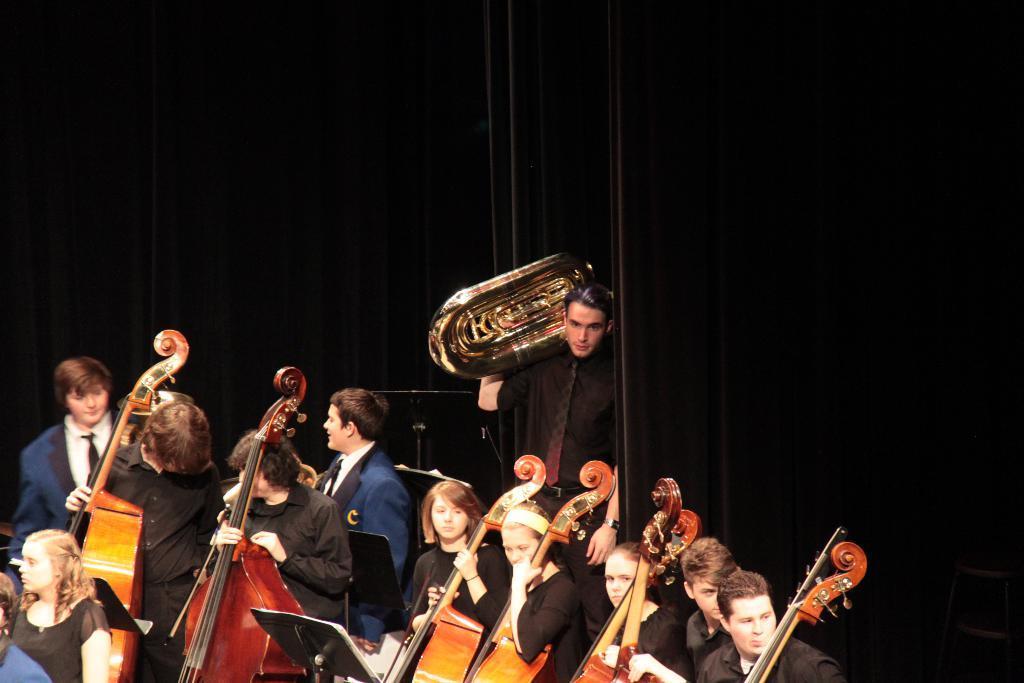Can you describe this image briefly? In the image few people are playing some musical instruments and standing. Behind them there is a curtain. 